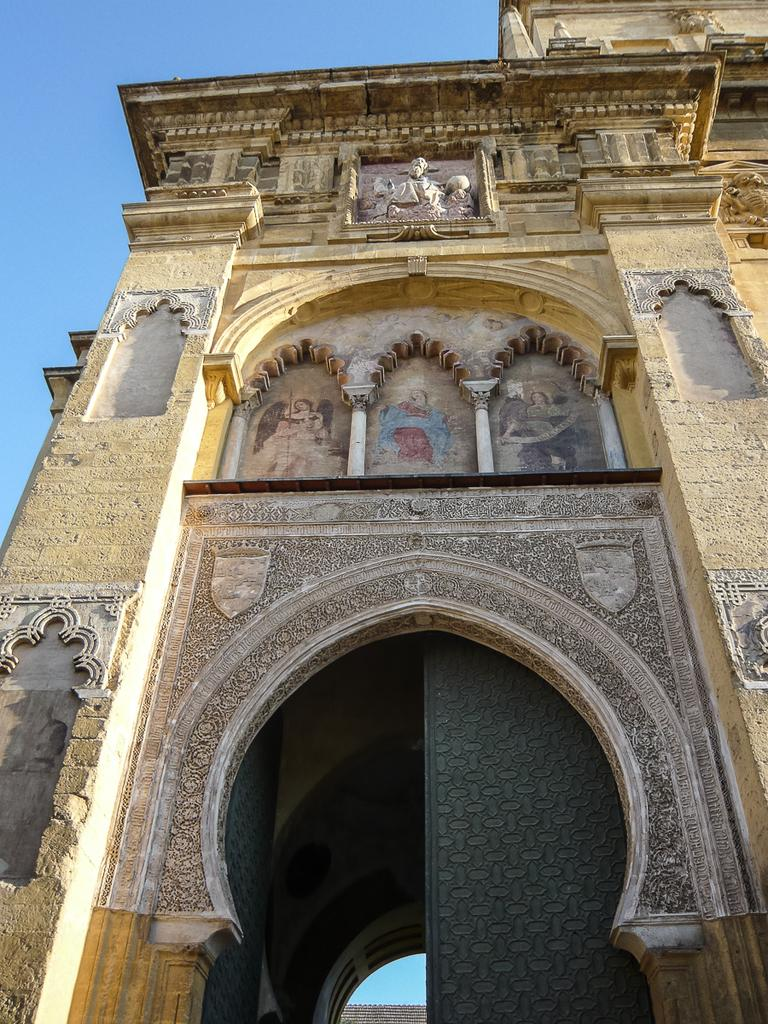What is the main structure in the picture? There is a building in the picture. What artistic elements can be seen on the building? The building has sculptures and designs on its walls. What type of canvas is being used by the artist in the picture? There is no artist or canvas present in the image; it features a building with sculptures and designs on its walls. 